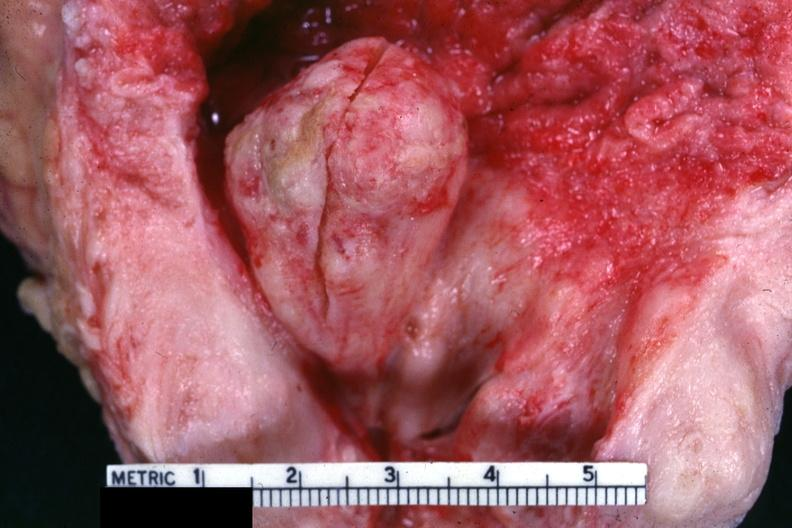s prostate present?
Answer the question using a single word or phrase. Yes 